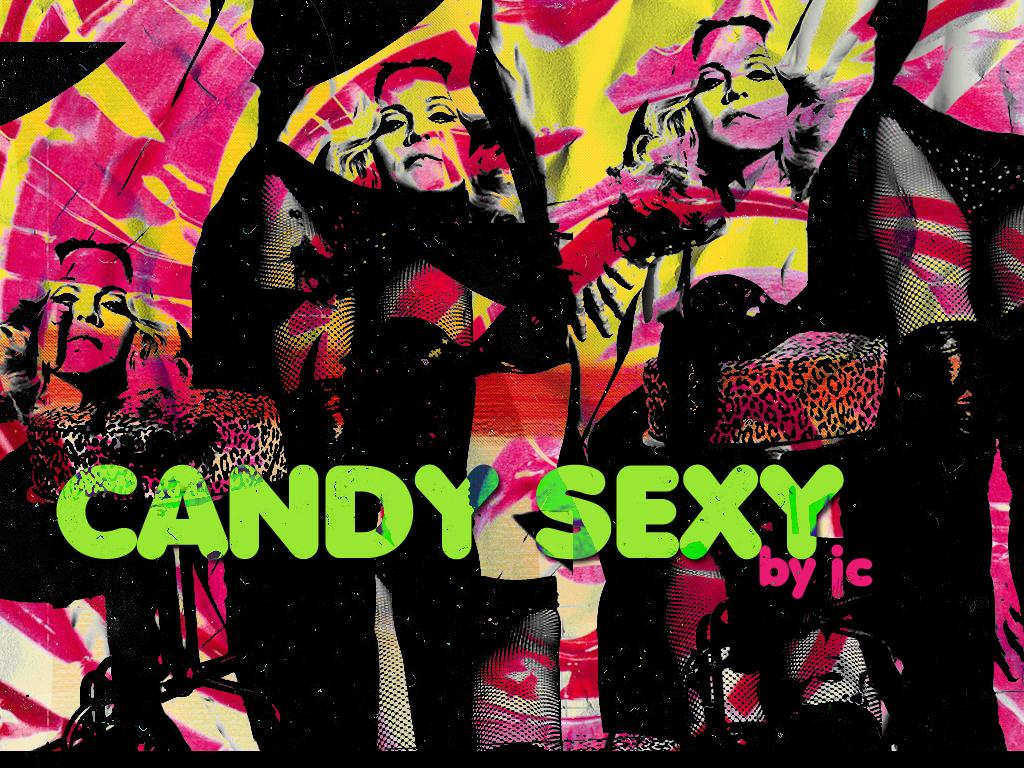What is the main subject of the image? The main subject of the image is depictions of women. Where are the women located in the image? The women are in the center of the image. Is there any text present in the image? Yes, there is some text in the image. What type of creature can be seen interacting with the hydrant in the image? There is no hydrant or creature present in the image; it only features depictions of women and some text. 